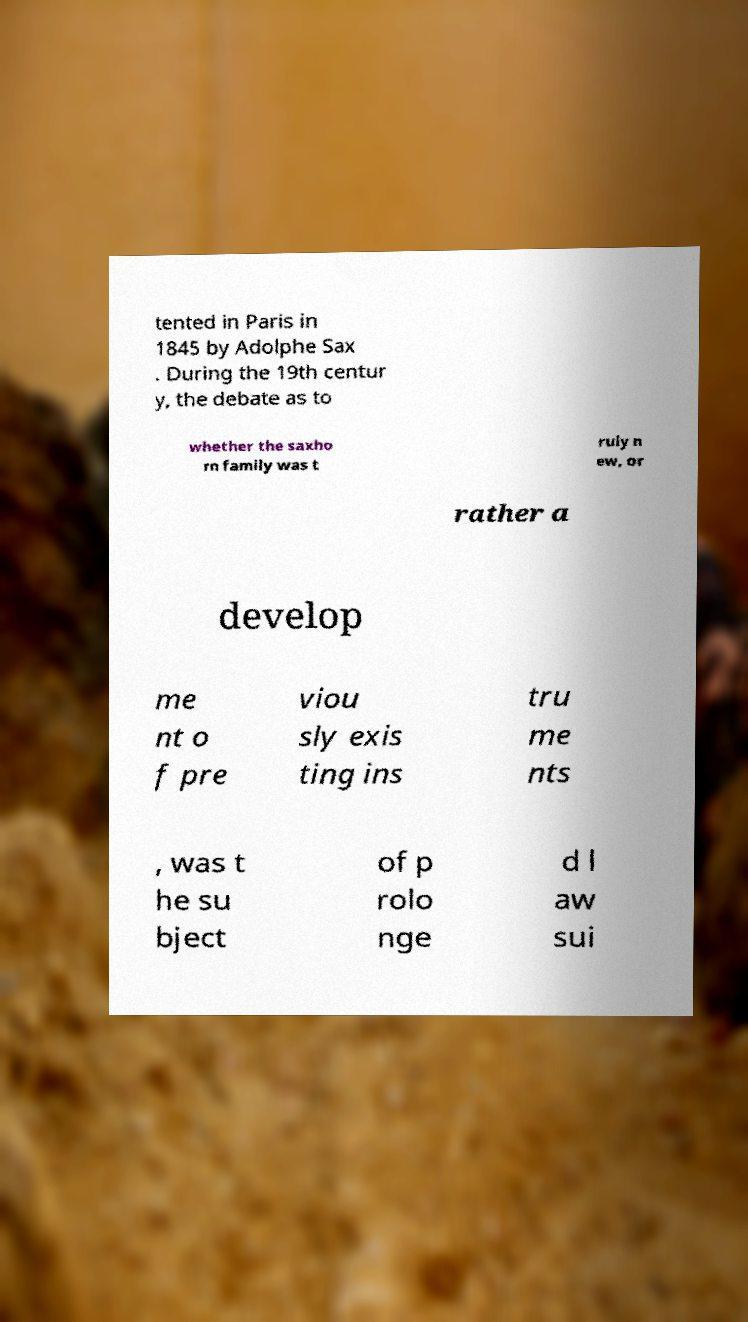There's text embedded in this image that I need extracted. Can you transcribe it verbatim? tented in Paris in 1845 by Adolphe Sax . During the 19th centur y, the debate as to whether the saxho rn family was t ruly n ew, or rather a develop me nt o f pre viou sly exis ting ins tru me nts , was t he su bject of p rolo nge d l aw sui 